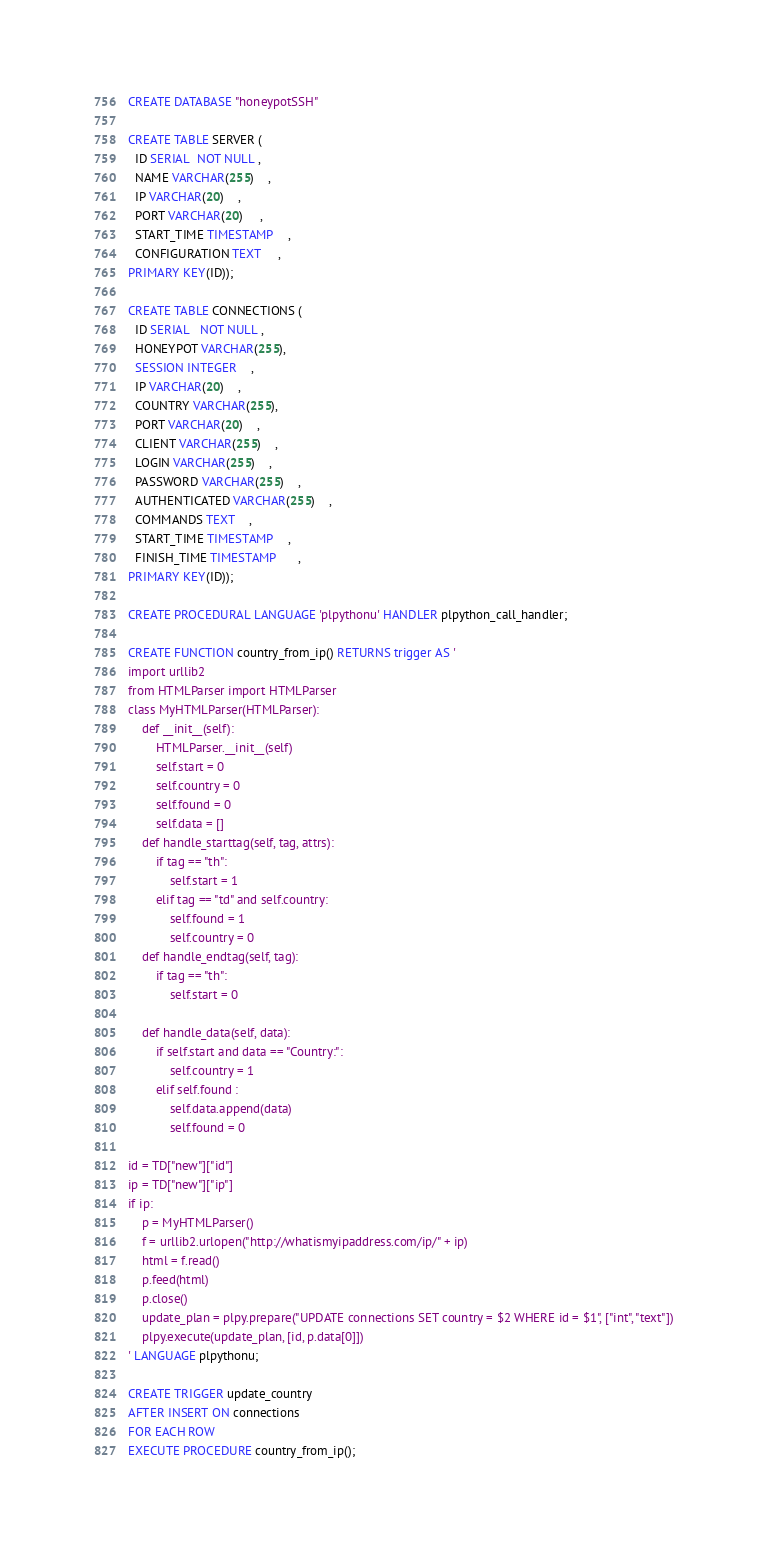Convert code to text. <code><loc_0><loc_0><loc_500><loc_500><_SQL_>CREATE DATABASE "honeypotSSH"

CREATE TABLE SERVER (
  ID SERIAL  NOT NULL ,
  NAME VARCHAR(255)    ,
  IP VARCHAR(20)    ,
  PORT VARCHAR(20)     ,
  START_TIME TIMESTAMP    ,
  CONFIGURATION TEXT     ,
PRIMARY KEY(ID));

CREATE TABLE CONNECTIONS (
  ID SERIAL   NOT NULL ,
  HONEYPOT VARCHAR(255), 
  SESSION INTEGER    ,
  IP VARCHAR(20)    ,
  COUNTRY VARCHAR(255),
  PORT VARCHAR(20)    ,
  CLIENT VARCHAR(255)    ,
  LOGIN VARCHAR(255)    ,
  PASSWORD VARCHAR(255)    ,
  AUTHENTICATED VARCHAR(255)    ,
  COMMANDS TEXT    ,
  START_TIME TIMESTAMP    ,
  FINISH_TIME TIMESTAMP      ,
PRIMARY KEY(ID));

CREATE PROCEDURAL LANGUAGE 'plpythonu' HANDLER plpython_call_handler; 

CREATE FUNCTION country_from_ip() RETURNS trigger AS '
import urllib2 
from HTMLParser import HTMLParser  
class MyHTMLParser(HTMLParser):
    def __init__(self):
        HTMLParser.__init__(self)
        self.start = 0 
        self.country = 0 
        self.found = 0 
        self.data = []
    def handle_starttag(self, tag, attrs):
        if tag == "th":
            self.start = 1
        elif tag == "td" and self.country:
            self.found = 1 
            self.country = 0
    def handle_endtag(self, tag):
        if tag == "th":
            self.start = 0 

    def handle_data(self, data):
        if self.start and data == "Country:":
            self.country = 1
        elif self.found :
            self.data.append(data)
            self.found = 0

id = TD["new"]["id"]
ip = TD["new"]["ip"]
if ip:
    p = MyHTMLParser()
    f = urllib2.urlopen("http://whatismyipaddress.com/ip/" + ip)
    html = f.read()
    p.feed(html)
    p.close()
    update_plan = plpy.prepare("UPDATE connections SET country = $2 WHERE id = $1", ["int", "text"])
    plpy.execute(update_plan, [id, p.data[0]])
' LANGUAGE plpythonu;

CREATE TRIGGER update_country
AFTER INSERT ON connections
FOR EACH ROW
EXECUTE PROCEDURE country_from_ip();</code> 